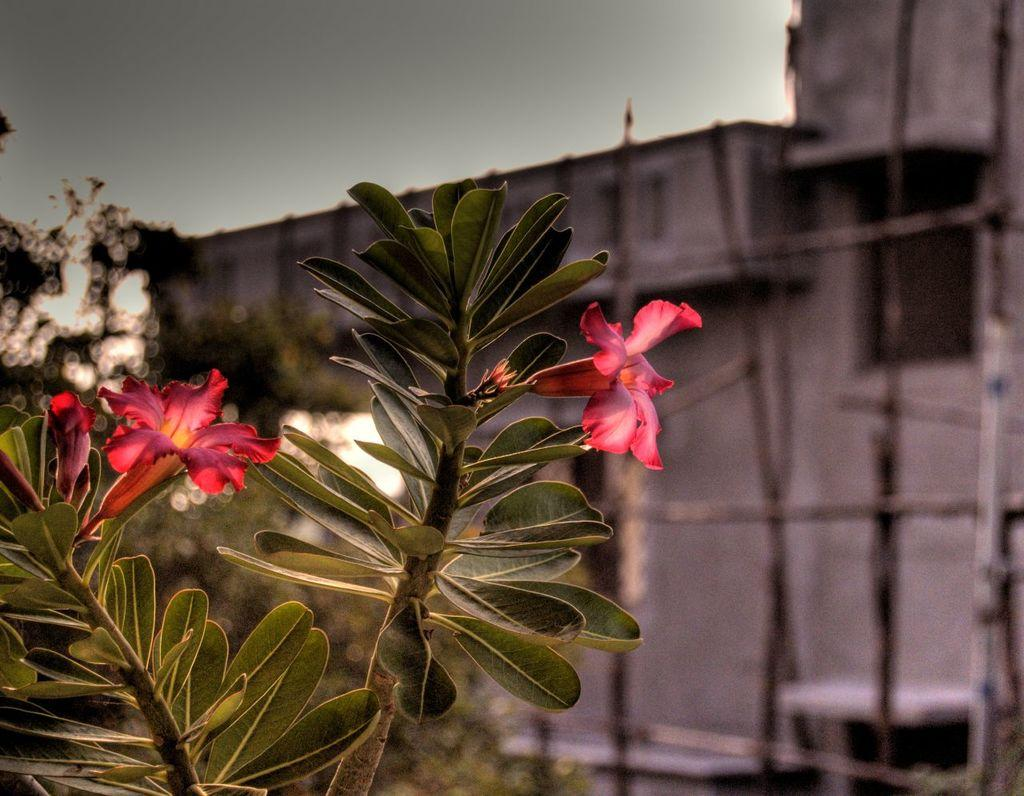What is located on the left side of the image? There is a plant and flowers on the left side of the image. What color are the flowers? The flowers are pink. What can be seen in the background of the image? There is a sky, at least one building, trees, and a few other objects visible in the background of the image. What is the price of the book in the library in the image? There is no library or book present in the image. What type of flight is visible in the sky in the image? There is no flight visible in the sky in the image. 